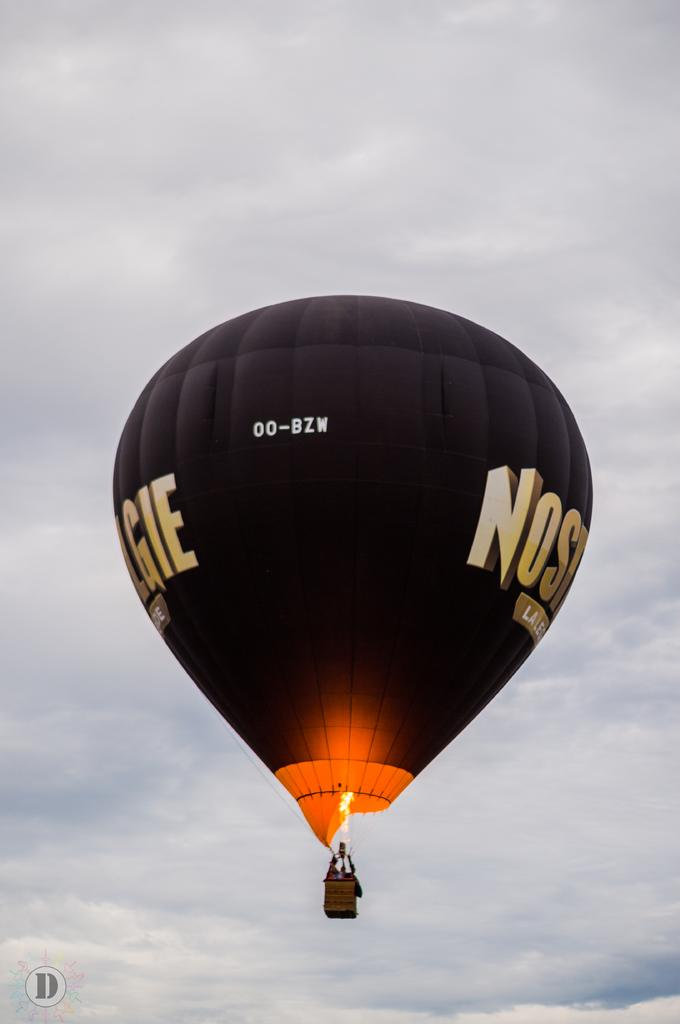What is the main subject of the image? The main subject of the image is a hot air balloon. Where is the hot air balloon located in the image? The hot air balloon is in the sky. What is the color of the hot air balloon? The hot air balloon is black in color. How does the hot air balloon provide comfort to the passengers in the image? The image does not show any passengers, so it is impossible to determine how the hot air balloon provides comfort. 